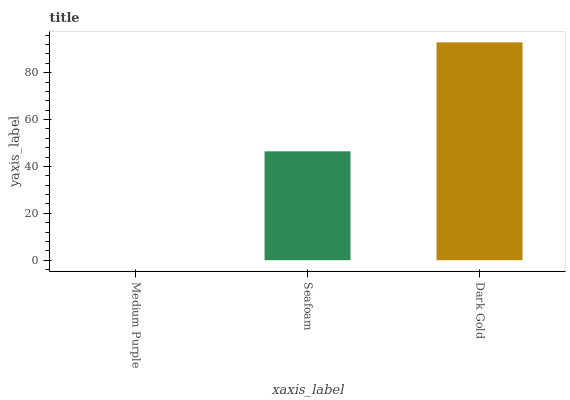Is Medium Purple the minimum?
Answer yes or no. Yes. Is Dark Gold the maximum?
Answer yes or no. Yes. Is Seafoam the minimum?
Answer yes or no. No. Is Seafoam the maximum?
Answer yes or no. No. Is Seafoam greater than Medium Purple?
Answer yes or no. Yes. Is Medium Purple less than Seafoam?
Answer yes or no. Yes. Is Medium Purple greater than Seafoam?
Answer yes or no. No. Is Seafoam less than Medium Purple?
Answer yes or no. No. Is Seafoam the high median?
Answer yes or no. Yes. Is Seafoam the low median?
Answer yes or no. Yes. Is Medium Purple the high median?
Answer yes or no. No. Is Medium Purple the low median?
Answer yes or no. No. 